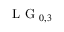<formula> <loc_0><loc_0><loc_500><loc_500>L G _ { 0 , 3 }</formula> 